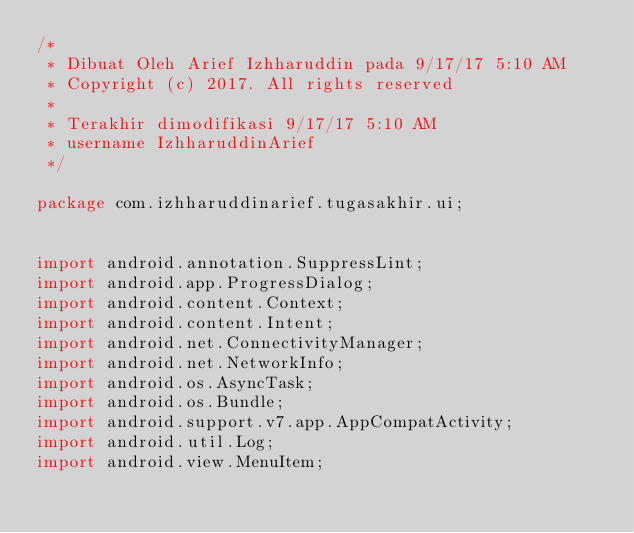<code> <loc_0><loc_0><loc_500><loc_500><_Java_>/*
 * Dibuat Oleh Arief Izhharuddin pada 9/17/17 5:10 AM
 * Copyright (c) 2017. All rights reserved
 *
 * Terakhir dimodifikasi 9/17/17 5:10 AM
 * username IzhharuddinArief
 */

package com.izhharuddinarief.tugasakhir.ui;


import android.annotation.SuppressLint;
import android.app.ProgressDialog;
import android.content.Context;
import android.content.Intent;
import android.net.ConnectivityManager;
import android.net.NetworkInfo;
import android.os.AsyncTask;
import android.os.Bundle;
import android.support.v7.app.AppCompatActivity;
import android.util.Log;
import android.view.MenuItem;</code> 